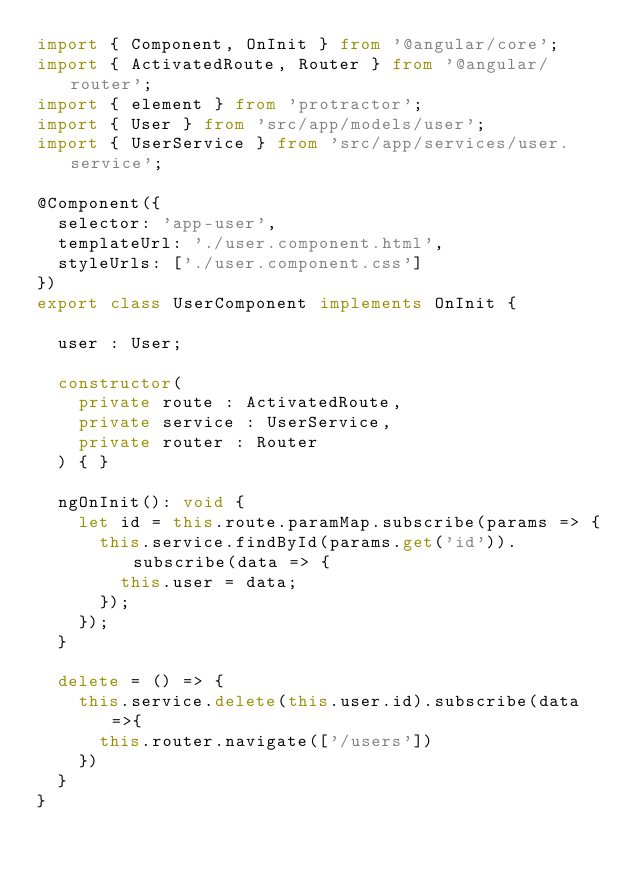Convert code to text. <code><loc_0><loc_0><loc_500><loc_500><_TypeScript_>import { Component, OnInit } from '@angular/core';
import { ActivatedRoute, Router } from '@angular/router';
import { element } from 'protractor';
import { User } from 'src/app/models/user';
import { UserService } from 'src/app/services/user.service';

@Component({
  selector: 'app-user',
  templateUrl: './user.component.html',
  styleUrls: ['./user.component.css']
})
export class UserComponent implements OnInit {

  user : User;

  constructor(
    private route : ActivatedRoute,
    private service : UserService,
    private router : Router
  ) { }

  ngOnInit(): void {
    let id = this.route.paramMap.subscribe(params => {
      this.service.findById(params.get('id')).subscribe(data => {
        this.user = data;
      });
    });
  }

  delete = () => {
    this.service.delete(this.user.id).subscribe(data =>{
      this.router.navigate(['/users'])
    })
  }
}
</code> 